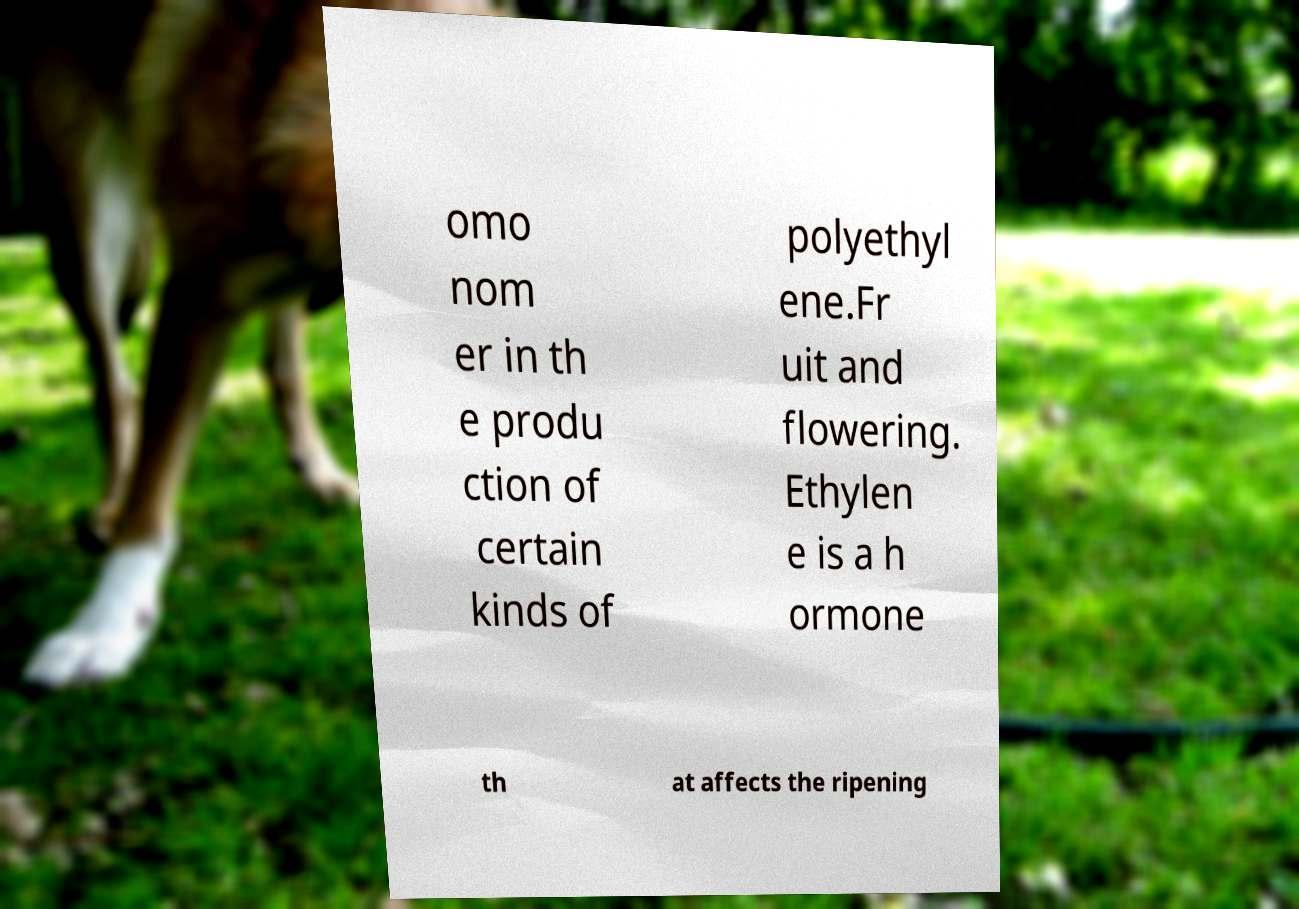Could you assist in decoding the text presented in this image and type it out clearly? omo nom er in th e produ ction of certain kinds of polyethyl ene.Fr uit and flowering. Ethylen e is a h ormone th at affects the ripening 